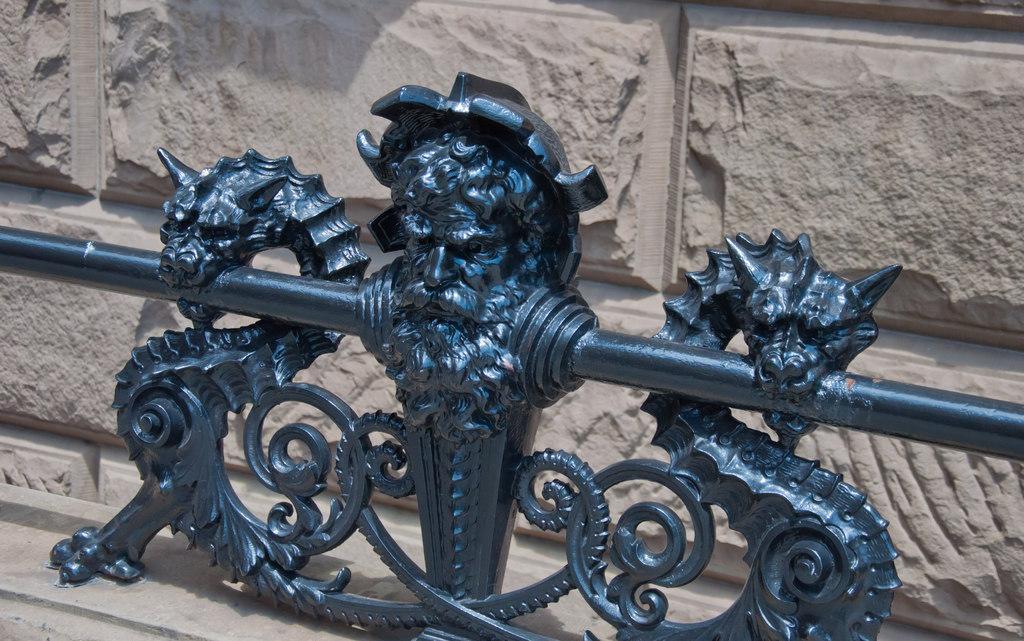Can you describe this image briefly? This image consists of a wall. In front of that there is something which is made of iron. 